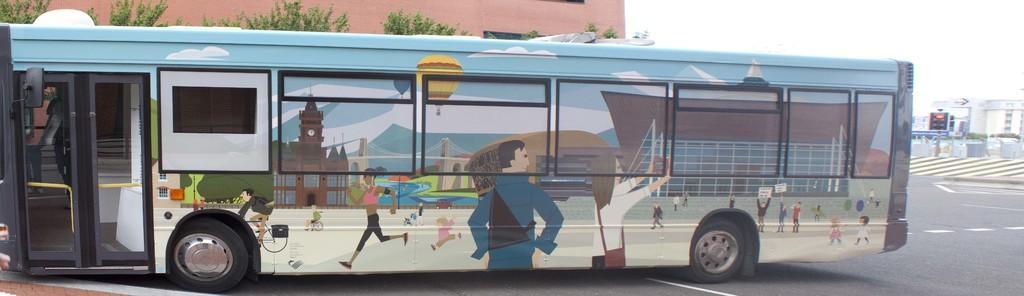How would you summarize this image in a sentence or two? In this image there is the sky towards the top of the image, there are buildings towards the right of the image, there is a traffic light, there is a wall towards the top of the image, there are trees towards the top of the image, there is road towards the bottom of the image, there is a bus on the road, there are buildings on the bus, there are a group of persons on the bus, there is a bridge on the bus, there are hot air balloons on the bus, there are clouds on the bus. 